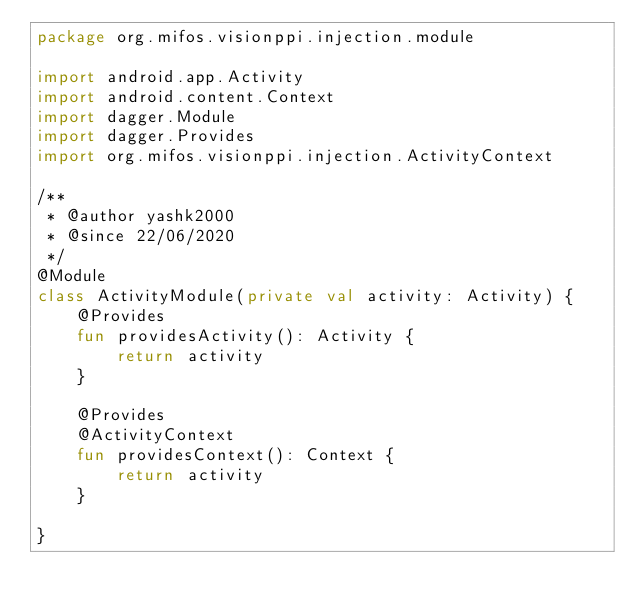<code> <loc_0><loc_0><loc_500><loc_500><_Kotlin_>package org.mifos.visionppi.injection.module

import android.app.Activity
import android.content.Context
import dagger.Module
import dagger.Provides
import org.mifos.visionppi.injection.ActivityContext

/**
 * @author yashk2000
 * @since 22/06/2020
 */
@Module
class ActivityModule(private val activity: Activity) {
    @Provides
    fun providesActivity(): Activity {
        return activity
    }

    @Provides
    @ActivityContext
    fun providesContext(): Context {
        return activity
    }

}</code> 